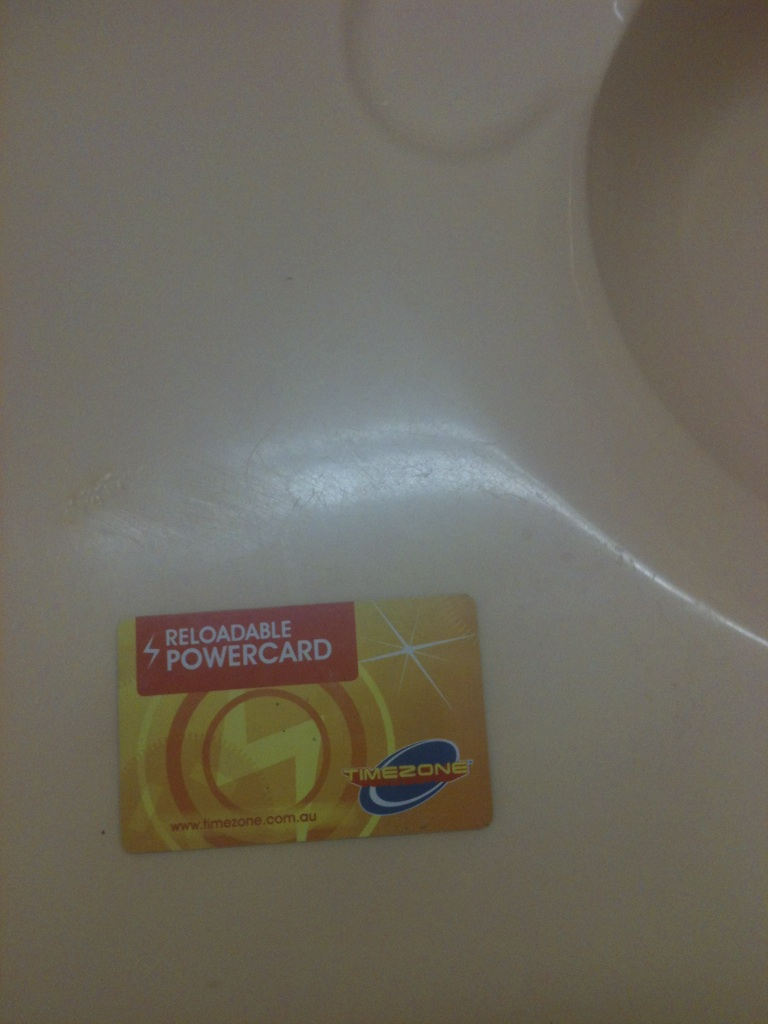Where can these cards be obtained? These cards can be obtained at any Timezone entertainment center. They are typically purchased at the front desk or kiosks located within the centers. Are there any special benefits to using a reloadable card instead of coins at these centers? Yes, using a reloadable card like the Timezone Powercard often comes with benefits such as convenience, safety from losing coins, and the ability to earn rewards. Some centers may offer bonus credits for reloading certain amounts, making it a cost-effective option for frequent visitors. 